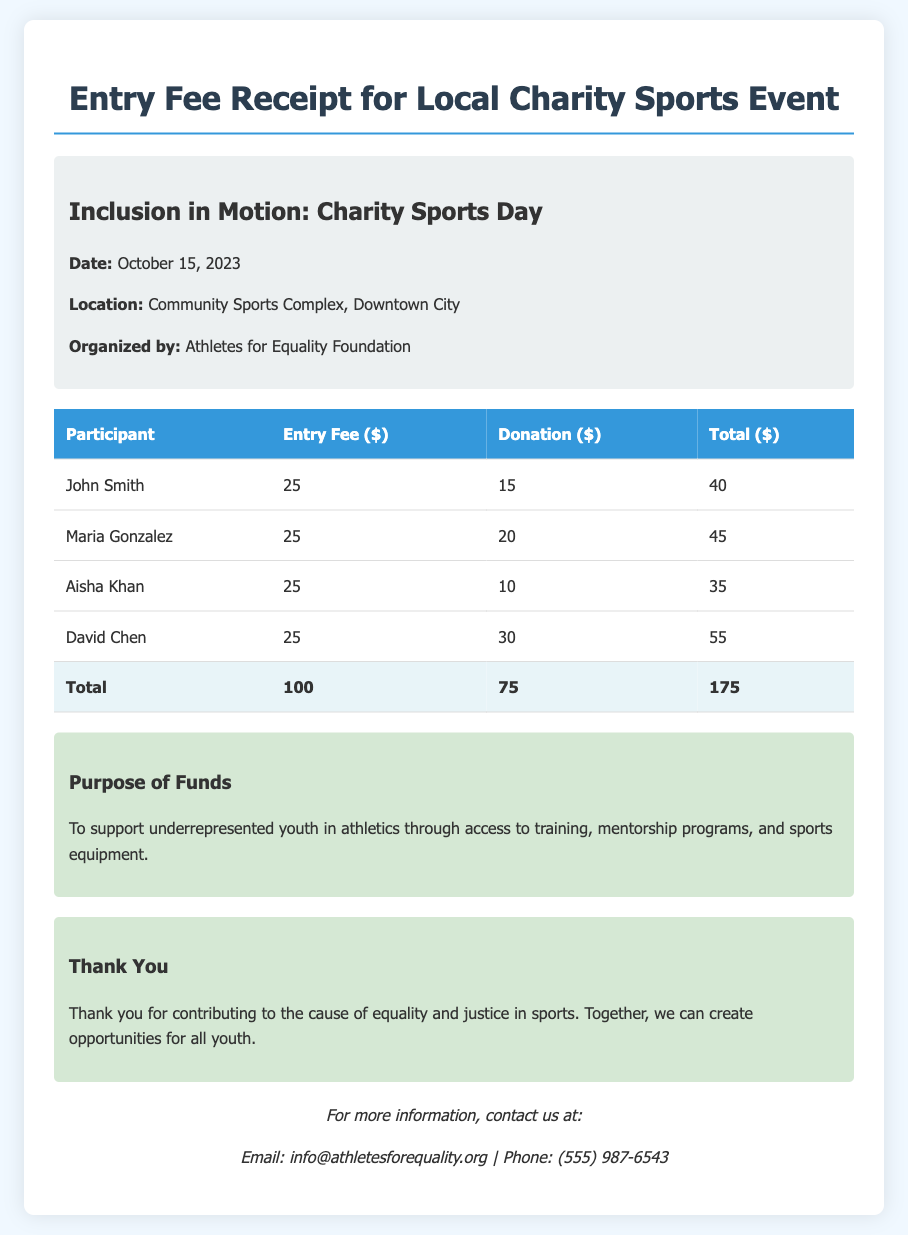What is the event name? The name of the event is stated in the title section of the document.
Answer: Inclusion in Motion: Charity Sports Day What is the total donation collected? The total donation is the sum of all donations listed in the table.
Answer: 75 Who organized the event? The organization that arranged the event is mentioned in the event details section.
Answer: Athletes for Equality Foundation What is the entry fee for each participant? The entry fee is the same for all participants, as displayed in the table.
Answer: 25 On what date did the event take place? The date of the event is provided in the event details section of the document.
Answer: October 15, 2023 What is the total revenue generated from entry fees? The total revenue from entry fees is computed from the total entry fees listed.
Answer: 100 What is the purpose of the funds raised? The purpose of the funds is highlighted in the dedicated section of the document.
Answer: To support underrepresented youth in athletics How many participants are listed in the document? The number of participants can be counted from the rows in the table.
Answer: 4 What is included in the contact information? The contact information contains details for reaching out, which is specified in the document.
Answer: Email and Phone 